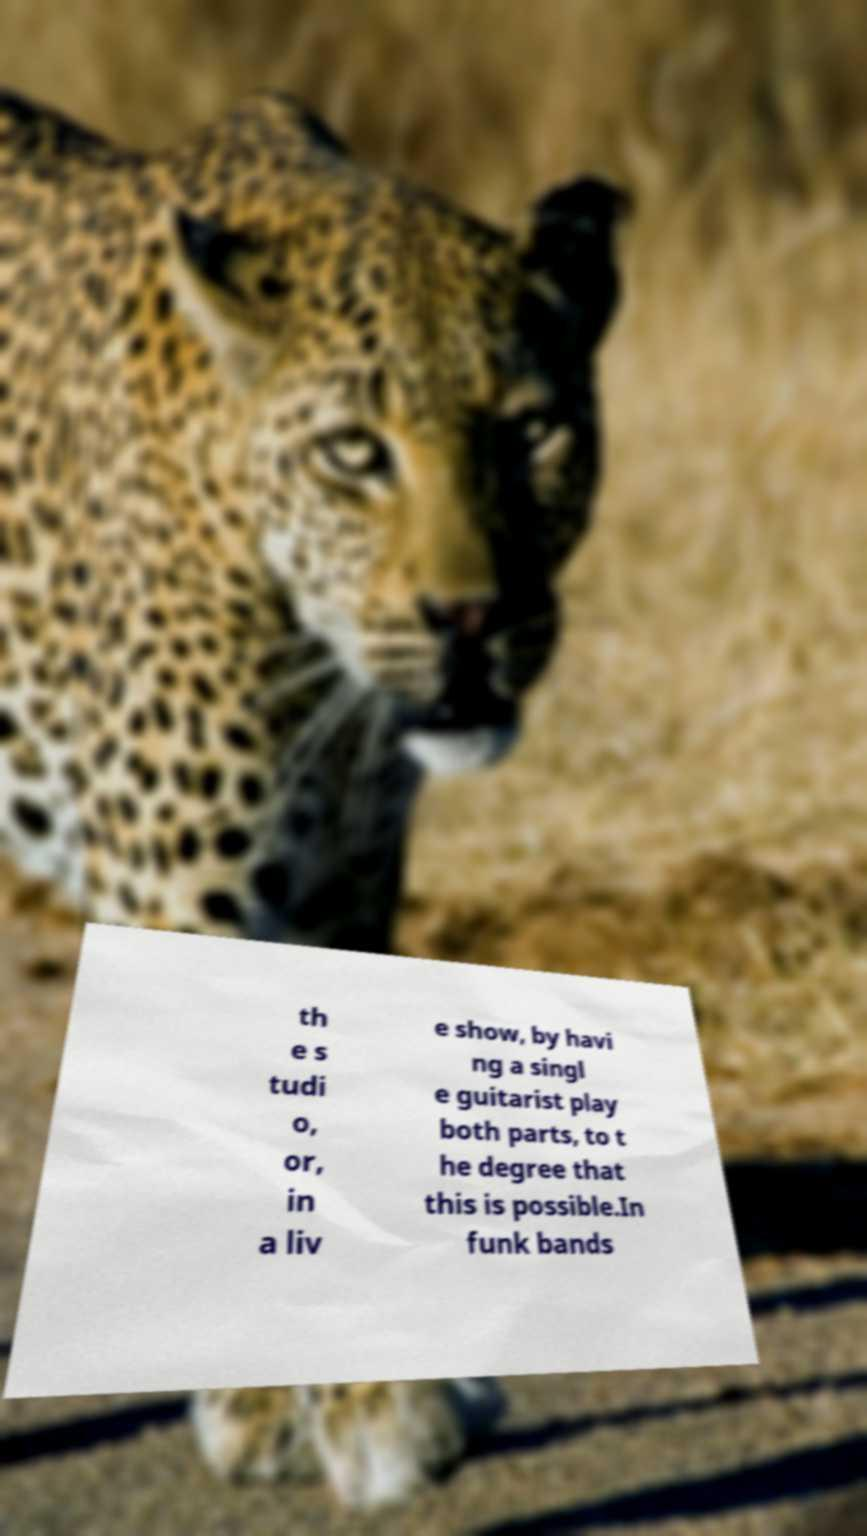Can you read and provide the text displayed in the image?This photo seems to have some interesting text. Can you extract and type it out for me? th e s tudi o, or, in a liv e show, by havi ng a singl e guitarist play both parts, to t he degree that this is possible.In funk bands 